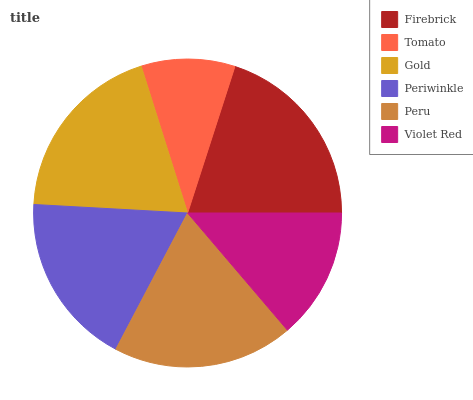Is Tomato the minimum?
Answer yes or no. Yes. Is Firebrick the maximum?
Answer yes or no. Yes. Is Gold the minimum?
Answer yes or no. No. Is Gold the maximum?
Answer yes or no. No. Is Gold greater than Tomato?
Answer yes or no. Yes. Is Tomato less than Gold?
Answer yes or no. Yes. Is Tomato greater than Gold?
Answer yes or no. No. Is Gold less than Tomato?
Answer yes or no. No. Is Peru the high median?
Answer yes or no. Yes. Is Periwinkle the low median?
Answer yes or no. Yes. Is Firebrick the high median?
Answer yes or no. No. Is Tomato the low median?
Answer yes or no. No. 